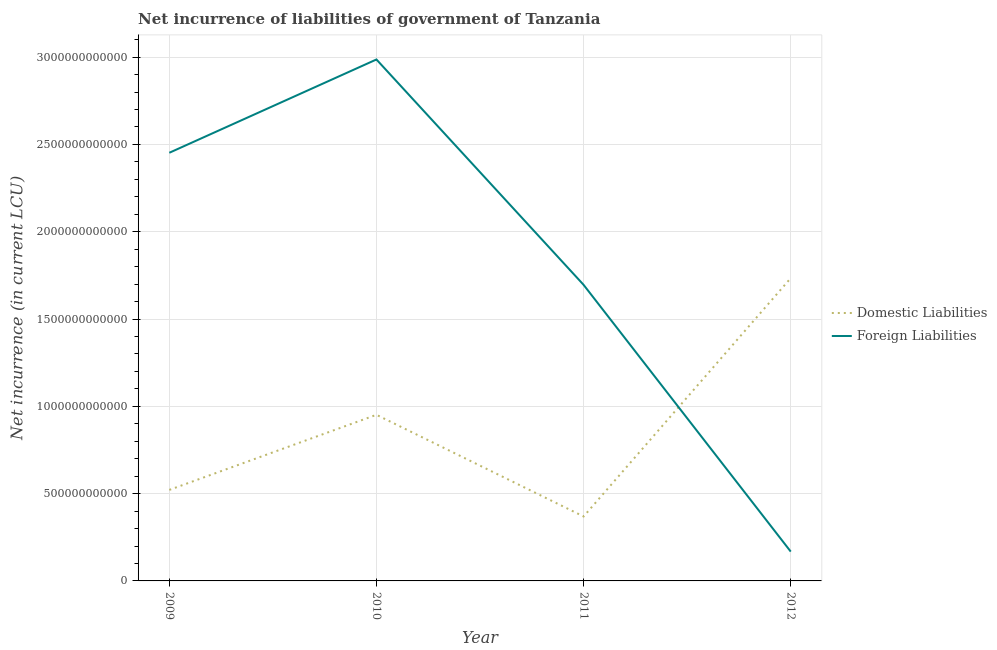What is the net incurrence of foreign liabilities in 2009?
Provide a succinct answer. 2.45e+12. Across all years, what is the maximum net incurrence of domestic liabilities?
Your response must be concise. 1.73e+12. Across all years, what is the minimum net incurrence of domestic liabilities?
Keep it short and to the point. 3.69e+11. In which year was the net incurrence of domestic liabilities maximum?
Make the answer very short. 2012. What is the total net incurrence of foreign liabilities in the graph?
Provide a succinct answer. 7.30e+12. What is the difference between the net incurrence of domestic liabilities in 2010 and that in 2012?
Ensure brevity in your answer.  -7.83e+11. What is the difference between the net incurrence of foreign liabilities in 2010 and the net incurrence of domestic liabilities in 2011?
Offer a very short reply. 2.62e+12. What is the average net incurrence of foreign liabilities per year?
Offer a terse response. 1.83e+12. In the year 2012, what is the difference between the net incurrence of domestic liabilities and net incurrence of foreign liabilities?
Provide a short and direct response. 1.57e+12. What is the ratio of the net incurrence of foreign liabilities in 2009 to that in 2012?
Your answer should be very brief. 14.6. Is the net incurrence of domestic liabilities in 2011 less than that in 2012?
Your response must be concise. Yes. Is the difference between the net incurrence of foreign liabilities in 2010 and 2011 greater than the difference between the net incurrence of domestic liabilities in 2010 and 2011?
Ensure brevity in your answer.  Yes. What is the difference between the highest and the second highest net incurrence of domestic liabilities?
Keep it short and to the point. 7.83e+11. What is the difference between the highest and the lowest net incurrence of foreign liabilities?
Your response must be concise. 2.82e+12. Does the net incurrence of domestic liabilities monotonically increase over the years?
Give a very brief answer. No. How many lines are there?
Give a very brief answer. 2. How many years are there in the graph?
Make the answer very short. 4. What is the difference between two consecutive major ticks on the Y-axis?
Make the answer very short. 5.00e+11. Does the graph contain any zero values?
Your response must be concise. No. Does the graph contain grids?
Give a very brief answer. Yes. Where does the legend appear in the graph?
Your answer should be very brief. Center right. What is the title of the graph?
Give a very brief answer. Net incurrence of liabilities of government of Tanzania. Does "Age 65(male)" appear as one of the legend labels in the graph?
Your answer should be very brief. No. What is the label or title of the Y-axis?
Your answer should be compact. Net incurrence (in current LCU). What is the Net incurrence (in current LCU) of Domestic Liabilities in 2009?
Offer a very short reply. 5.21e+11. What is the Net incurrence (in current LCU) in Foreign Liabilities in 2009?
Provide a short and direct response. 2.45e+12. What is the Net incurrence (in current LCU) of Domestic Liabilities in 2010?
Provide a succinct answer. 9.51e+11. What is the Net incurrence (in current LCU) in Foreign Liabilities in 2010?
Your response must be concise. 2.99e+12. What is the Net incurrence (in current LCU) in Domestic Liabilities in 2011?
Make the answer very short. 3.69e+11. What is the Net incurrence (in current LCU) of Foreign Liabilities in 2011?
Your answer should be compact. 1.70e+12. What is the Net incurrence (in current LCU) of Domestic Liabilities in 2012?
Provide a short and direct response. 1.73e+12. What is the Net incurrence (in current LCU) in Foreign Liabilities in 2012?
Your answer should be very brief. 1.68e+11. Across all years, what is the maximum Net incurrence (in current LCU) of Domestic Liabilities?
Provide a short and direct response. 1.73e+12. Across all years, what is the maximum Net incurrence (in current LCU) of Foreign Liabilities?
Offer a terse response. 2.99e+12. Across all years, what is the minimum Net incurrence (in current LCU) of Domestic Liabilities?
Your response must be concise. 3.69e+11. Across all years, what is the minimum Net incurrence (in current LCU) in Foreign Liabilities?
Keep it short and to the point. 1.68e+11. What is the total Net incurrence (in current LCU) of Domestic Liabilities in the graph?
Give a very brief answer. 3.58e+12. What is the total Net incurrence (in current LCU) of Foreign Liabilities in the graph?
Keep it short and to the point. 7.30e+12. What is the difference between the Net incurrence (in current LCU) in Domestic Liabilities in 2009 and that in 2010?
Make the answer very short. -4.30e+11. What is the difference between the Net incurrence (in current LCU) of Foreign Liabilities in 2009 and that in 2010?
Your answer should be compact. -5.34e+11. What is the difference between the Net incurrence (in current LCU) of Domestic Liabilities in 2009 and that in 2011?
Your response must be concise. 1.52e+11. What is the difference between the Net incurrence (in current LCU) of Foreign Liabilities in 2009 and that in 2011?
Give a very brief answer. 7.56e+11. What is the difference between the Net incurrence (in current LCU) of Domestic Liabilities in 2009 and that in 2012?
Provide a short and direct response. -1.21e+12. What is the difference between the Net incurrence (in current LCU) in Foreign Liabilities in 2009 and that in 2012?
Your answer should be very brief. 2.28e+12. What is the difference between the Net incurrence (in current LCU) of Domestic Liabilities in 2010 and that in 2011?
Offer a terse response. 5.82e+11. What is the difference between the Net incurrence (in current LCU) of Foreign Liabilities in 2010 and that in 2011?
Provide a short and direct response. 1.29e+12. What is the difference between the Net incurrence (in current LCU) in Domestic Liabilities in 2010 and that in 2012?
Your answer should be very brief. -7.83e+11. What is the difference between the Net incurrence (in current LCU) of Foreign Liabilities in 2010 and that in 2012?
Offer a terse response. 2.82e+12. What is the difference between the Net incurrence (in current LCU) in Domestic Liabilities in 2011 and that in 2012?
Offer a very short reply. -1.37e+12. What is the difference between the Net incurrence (in current LCU) of Foreign Liabilities in 2011 and that in 2012?
Give a very brief answer. 1.53e+12. What is the difference between the Net incurrence (in current LCU) of Domestic Liabilities in 2009 and the Net incurrence (in current LCU) of Foreign Liabilities in 2010?
Provide a short and direct response. -2.47e+12. What is the difference between the Net incurrence (in current LCU) in Domestic Liabilities in 2009 and the Net incurrence (in current LCU) in Foreign Liabilities in 2011?
Ensure brevity in your answer.  -1.17e+12. What is the difference between the Net incurrence (in current LCU) in Domestic Liabilities in 2009 and the Net incurrence (in current LCU) in Foreign Liabilities in 2012?
Your response must be concise. 3.53e+11. What is the difference between the Net incurrence (in current LCU) in Domestic Liabilities in 2010 and the Net incurrence (in current LCU) in Foreign Liabilities in 2011?
Your answer should be very brief. -7.44e+11. What is the difference between the Net incurrence (in current LCU) of Domestic Liabilities in 2010 and the Net incurrence (in current LCU) of Foreign Liabilities in 2012?
Provide a short and direct response. 7.83e+11. What is the difference between the Net incurrence (in current LCU) in Domestic Liabilities in 2011 and the Net incurrence (in current LCU) in Foreign Liabilities in 2012?
Give a very brief answer. 2.01e+11. What is the average Net incurrence (in current LCU) in Domestic Liabilities per year?
Your answer should be compact. 8.94e+11. What is the average Net incurrence (in current LCU) in Foreign Liabilities per year?
Offer a very short reply. 1.83e+12. In the year 2009, what is the difference between the Net incurrence (in current LCU) in Domestic Liabilities and Net incurrence (in current LCU) in Foreign Liabilities?
Your answer should be compact. -1.93e+12. In the year 2010, what is the difference between the Net incurrence (in current LCU) of Domestic Liabilities and Net incurrence (in current LCU) of Foreign Liabilities?
Offer a terse response. -2.04e+12. In the year 2011, what is the difference between the Net incurrence (in current LCU) in Domestic Liabilities and Net incurrence (in current LCU) in Foreign Liabilities?
Offer a terse response. -1.33e+12. In the year 2012, what is the difference between the Net incurrence (in current LCU) in Domestic Liabilities and Net incurrence (in current LCU) in Foreign Liabilities?
Offer a terse response. 1.57e+12. What is the ratio of the Net incurrence (in current LCU) in Domestic Liabilities in 2009 to that in 2010?
Provide a succinct answer. 0.55. What is the ratio of the Net incurrence (in current LCU) of Foreign Liabilities in 2009 to that in 2010?
Your response must be concise. 0.82. What is the ratio of the Net incurrence (in current LCU) of Domestic Liabilities in 2009 to that in 2011?
Ensure brevity in your answer.  1.41. What is the ratio of the Net incurrence (in current LCU) of Foreign Liabilities in 2009 to that in 2011?
Make the answer very short. 1.45. What is the ratio of the Net incurrence (in current LCU) of Domestic Liabilities in 2009 to that in 2012?
Your answer should be compact. 0.3. What is the ratio of the Net incurrence (in current LCU) in Foreign Liabilities in 2009 to that in 2012?
Give a very brief answer. 14.6. What is the ratio of the Net incurrence (in current LCU) of Domestic Liabilities in 2010 to that in 2011?
Give a very brief answer. 2.58. What is the ratio of the Net incurrence (in current LCU) of Foreign Liabilities in 2010 to that in 2011?
Your answer should be compact. 1.76. What is the ratio of the Net incurrence (in current LCU) in Domestic Liabilities in 2010 to that in 2012?
Provide a succinct answer. 0.55. What is the ratio of the Net incurrence (in current LCU) in Foreign Liabilities in 2010 to that in 2012?
Provide a short and direct response. 17.79. What is the ratio of the Net incurrence (in current LCU) of Domestic Liabilities in 2011 to that in 2012?
Provide a succinct answer. 0.21. What is the ratio of the Net incurrence (in current LCU) of Foreign Liabilities in 2011 to that in 2012?
Provide a succinct answer. 10.1. What is the difference between the highest and the second highest Net incurrence (in current LCU) in Domestic Liabilities?
Offer a terse response. 7.83e+11. What is the difference between the highest and the second highest Net incurrence (in current LCU) in Foreign Liabilities?
Make the answer very short. 5.34e+11. What is the difference between the highest and the lowest Net incurrence (in current LCU) of Domestic Liabilities?
Provide a short and direct response. 1.37e+12. What is the difference between the highest and the lowest Net incurrence (in current LCU) in Foreign Liabilities?
Give a very brief answer. 2.82e+12. 